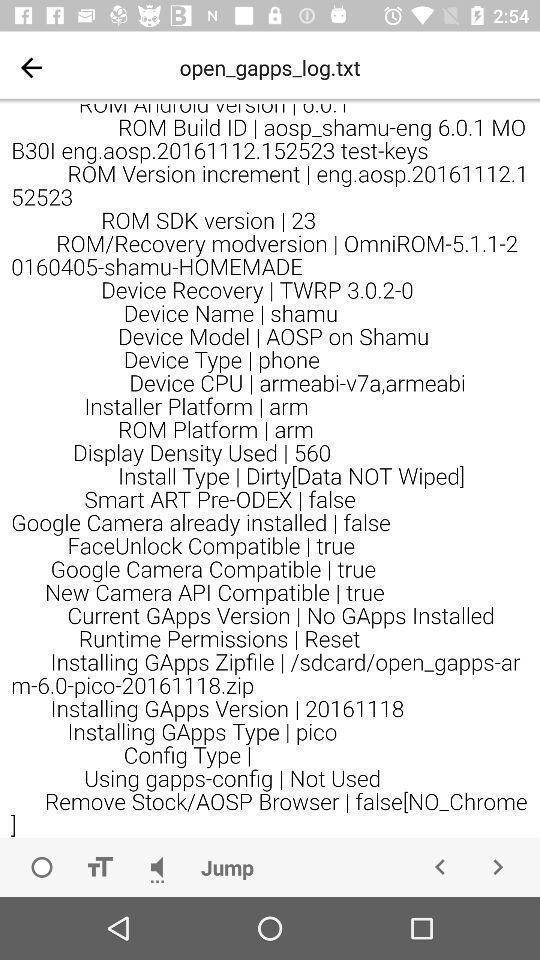Provide a detailed account of this screenshot. Screen displays information on a device. 